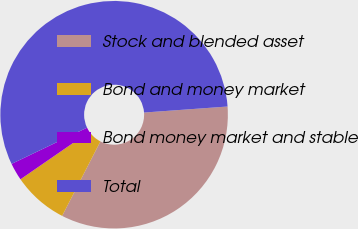Convert chart. <chart><loc_0><loc_0><loc_500><loc_500><pie_chart><fcel>Stock and blended asset<fcel>Bond and money market<fcel>Bond money market and stable<fcel>Total<nl><fcel>33.7%<fcel>7.84%<fcel>2.49%<fcel>55.97%<nl></chart> 